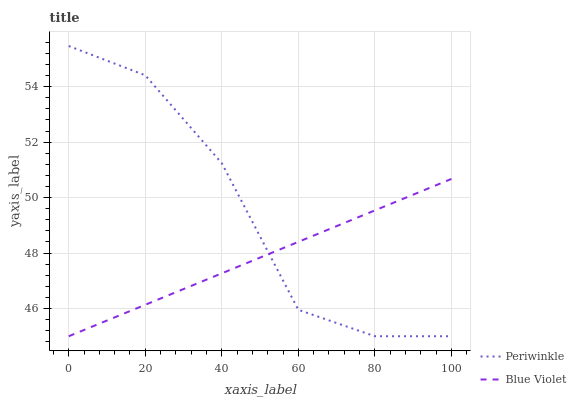Does Blue Violet have the minimum area under the curve?
Answer yes or no. Yes. Does Periwinkle have the maximum area under the curve?
Answer yes or no. Yes. Does Blue Violet have the maximum area under the curve?
Answer yes or no. No. Is Blue Violet the smoothest?
Answer yes or no. Yes. Is Periwinkle the roughest?
Answer yes or no. Yes. Is Blue Violet the roughest?
Answer yes or no. No. Does Periwinkle have the lowest value?
Answer yes or no. Yes. Does Periwinkle have the highest value?
Answer yes or no. Yes. Does Blue Violet have the highest value?
Answer yes or no. No. Does Blue Violet intersect Periwinkle?
Answer yes or no. Yes. Is Blue Violet less than Periwinkle?
Answer yes or no. No. Is Blue Violet greater than Periwinkle?
Answer yes or no. No. 